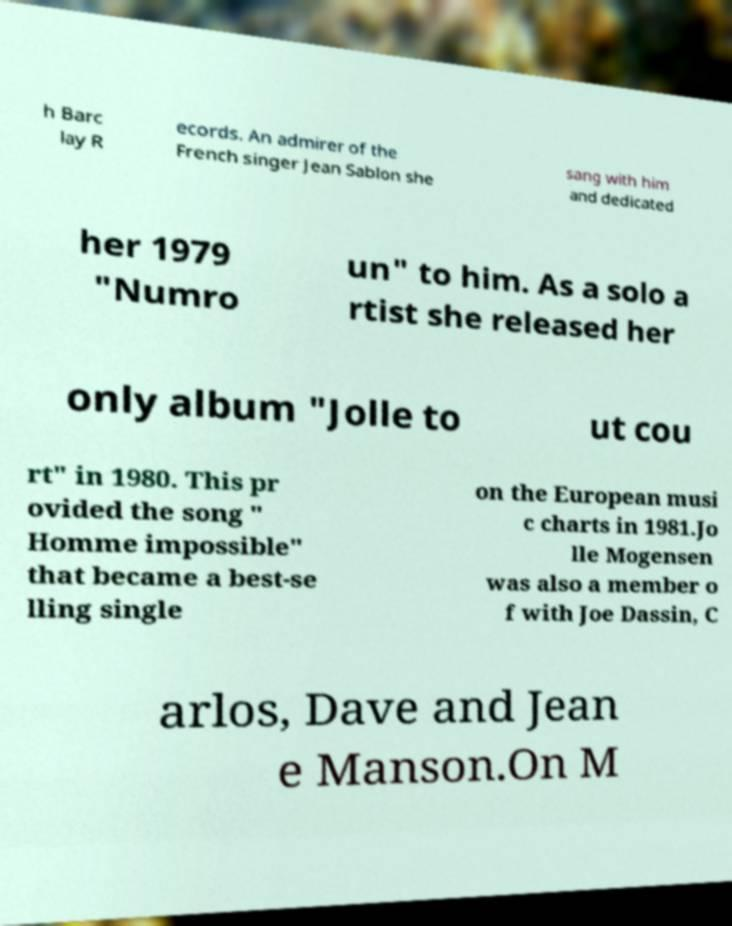Can you read and provide the text displayed in the image?This photo seems to have some interesting text. Can you extract and type it out for me? h Barc lay R ecords. An admirer of the French singer Jean Sablon she sang with him and dedicated her 1979 "Numro un" to him. As a solo a rtist she released her only album "Jolle to ut cou rt" in 1980. This pr ovided the song " Homme impossible" that became a best-se lling single on the European musi c charts in 1981.Jo lle Mogensen was also a member o f with Joe Dassin, C arlos, Dave and Jean e Manson.On M 